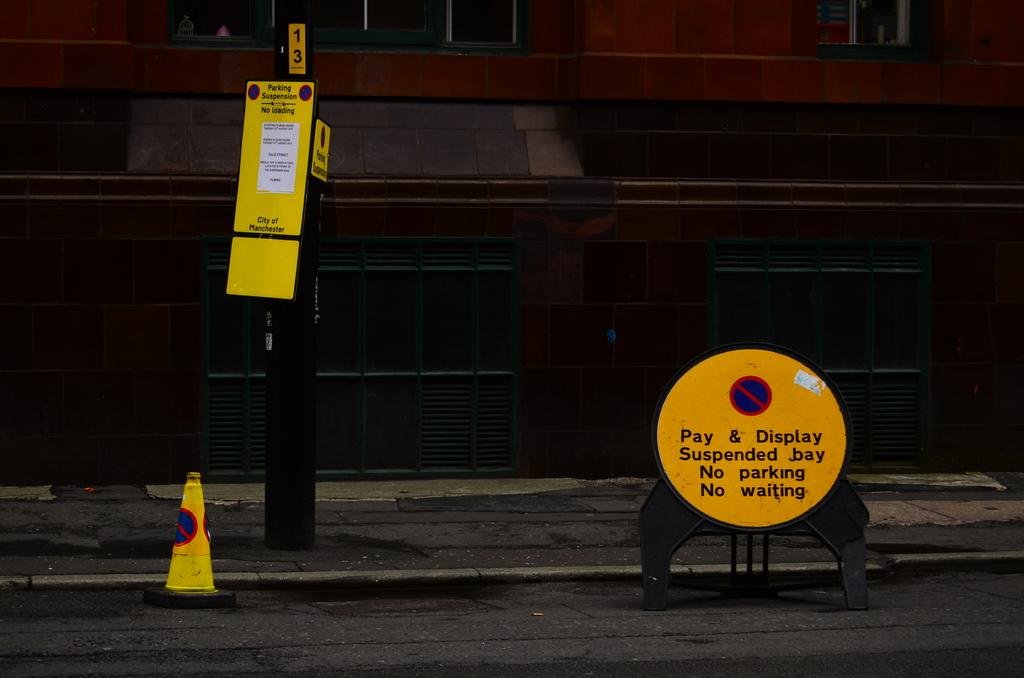<image>
Relay a brief, clear account of the picture shown. An orange circular street sign on the curb that says no parking and no waiting. 